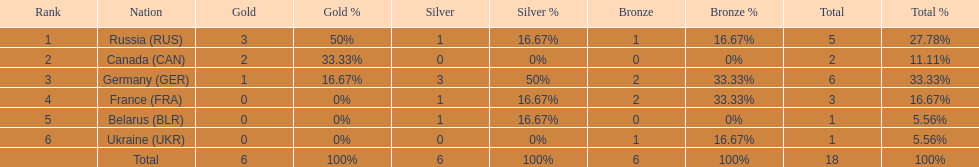Which country won the same amount of silver medals as the french and the russians? Belarus. 